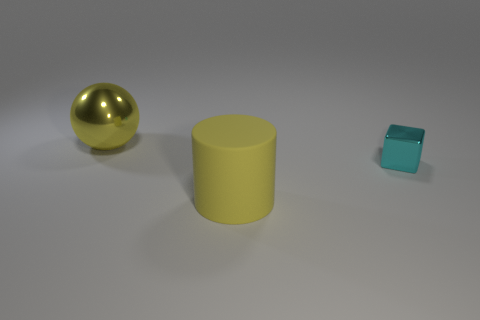Based on the colors in the image, what mood do they convey? The image conveys a calm and minimalist mood. The muted yellow of the cylinder and the cool teal of the cube contrast softly with each other, while the golden sphere adds a touch of warmth and sophistication to the scene. The simplicity and cleanliness of the colors could suggest a modern and tranquil atmosphere. 